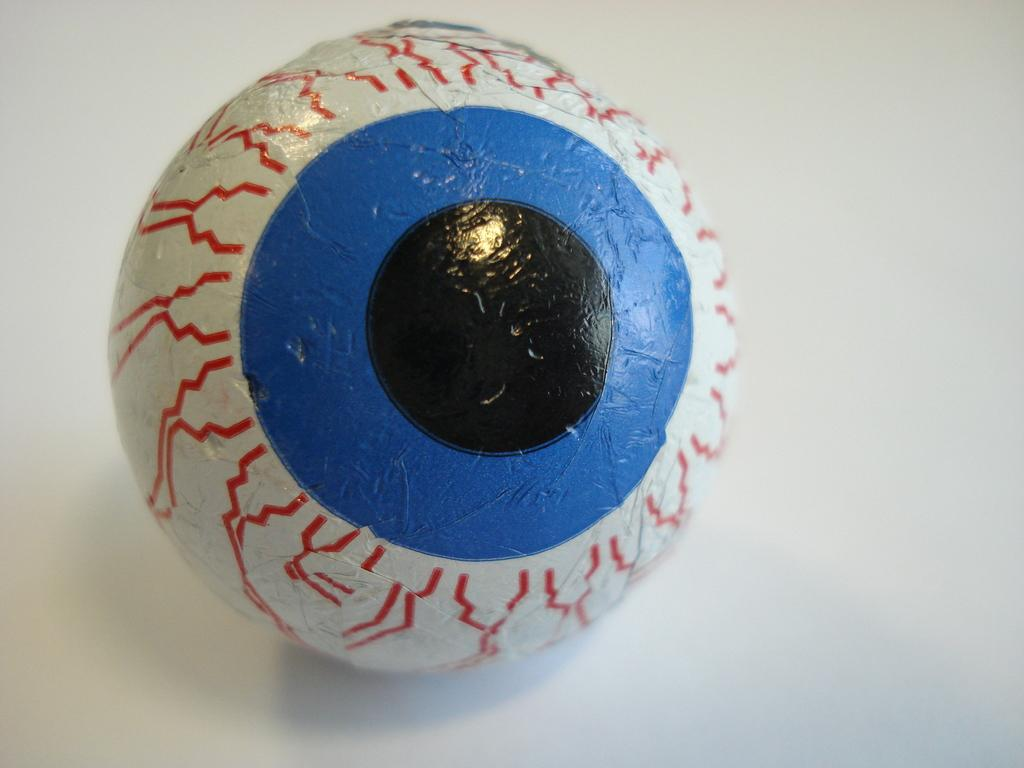What object is the main subject of the image? There is a ball in the image. What colors can be seen on the ball? The ball has white, red, blue, and black colors. What color is the background of the image? The background of the image is white. Can you see a ghost interacting with the ball in the image? There is no ghost present in the image, and therefore no such interaction can be observed. 